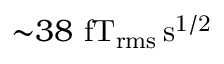<formula> <loc_0><loc_0><loc_500><loc_500>{ \sim } 3 8 f T _ { r m s } \, s ^ { 1 / 2 }</formula> 